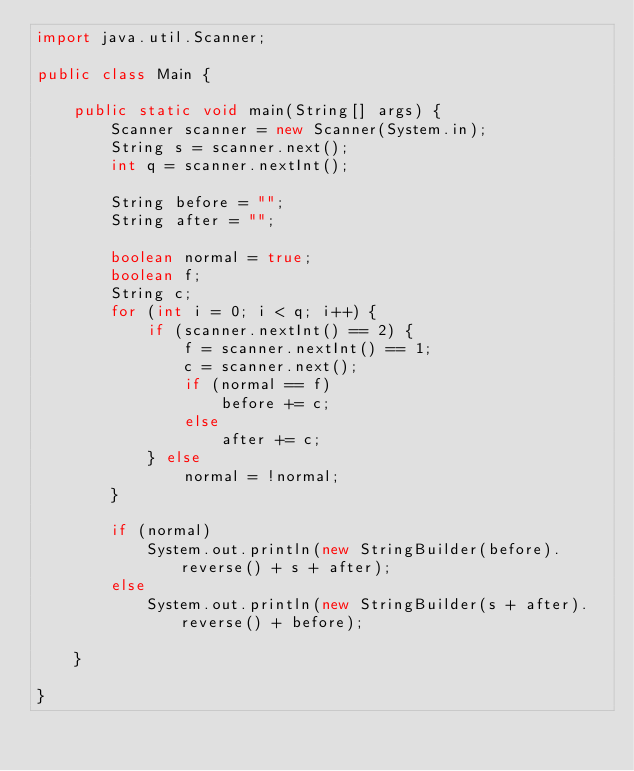Convert code to text. <code><loc_0><loc_0><loc_500><loc_500><_Java_>import java.util.Scanner;

public class Main {

	public static void main(String[] args) {
		Scanner scanner = new Scanner(System.in);
		String s = scanner.next();
		int q = scanner.nextInt();

		String before = "";
		String after = "";

		boolean normal = true;
		boolean f;
		String c;
		for (int i = 0; i < q; i++) {
			if (scanner.nextInt() == 2) {
				f = scanner.nextInt() == 1;
				c = scanner.next();
				if (normal == f)
					before += c;
				else
					after += c;
			} else
				normal = !normal;
		}

		if (normal)
			System.out.println(new StringBuilder(before).reverse() + s + after);
		else
			System.out.println(new StringBuilder(s + after).reverse() + before);

	}

}
</code> 